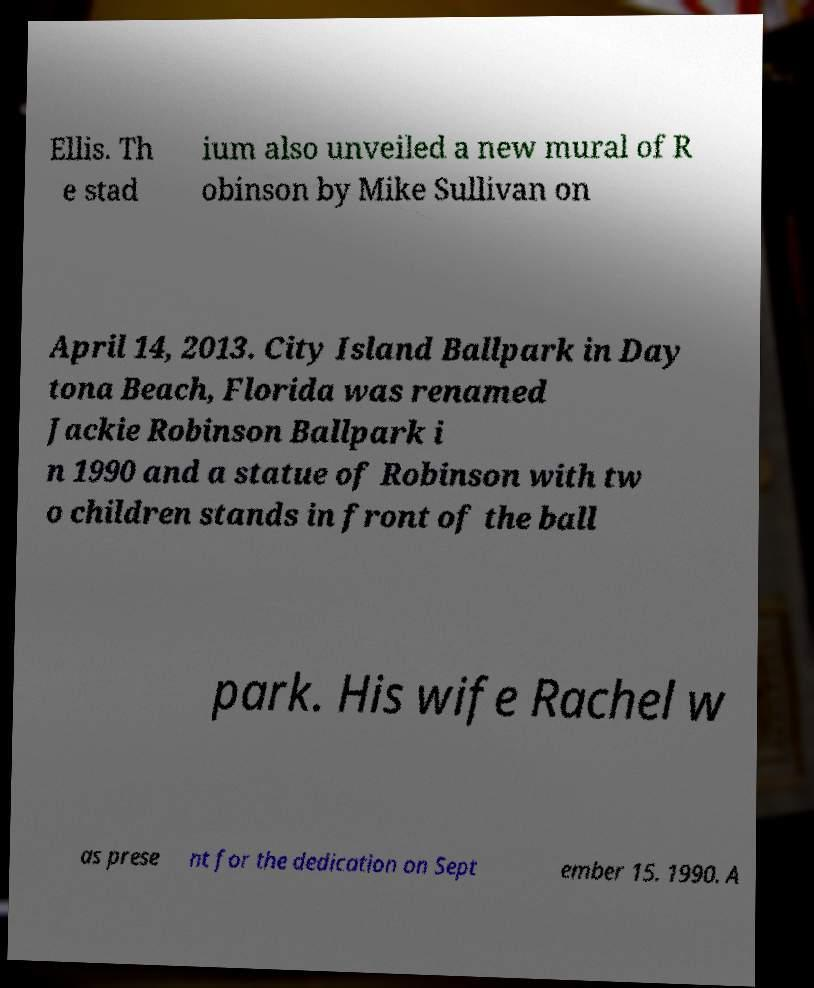Could you extract and type out the text from this image? Ellis. Th e stad ium also unveiled a new mural of R obinson by Mike Sullivan on April 14, 2013. City Island Ballpark in Day tona Beach, Florida was renamed Jackie Robinson Ballpark i n 1990 and a statue of Robinson with tw o children stands in front of the ball park. His wife Rachel w as prese nt for the dedication on Sept ember 15. 1990. A 